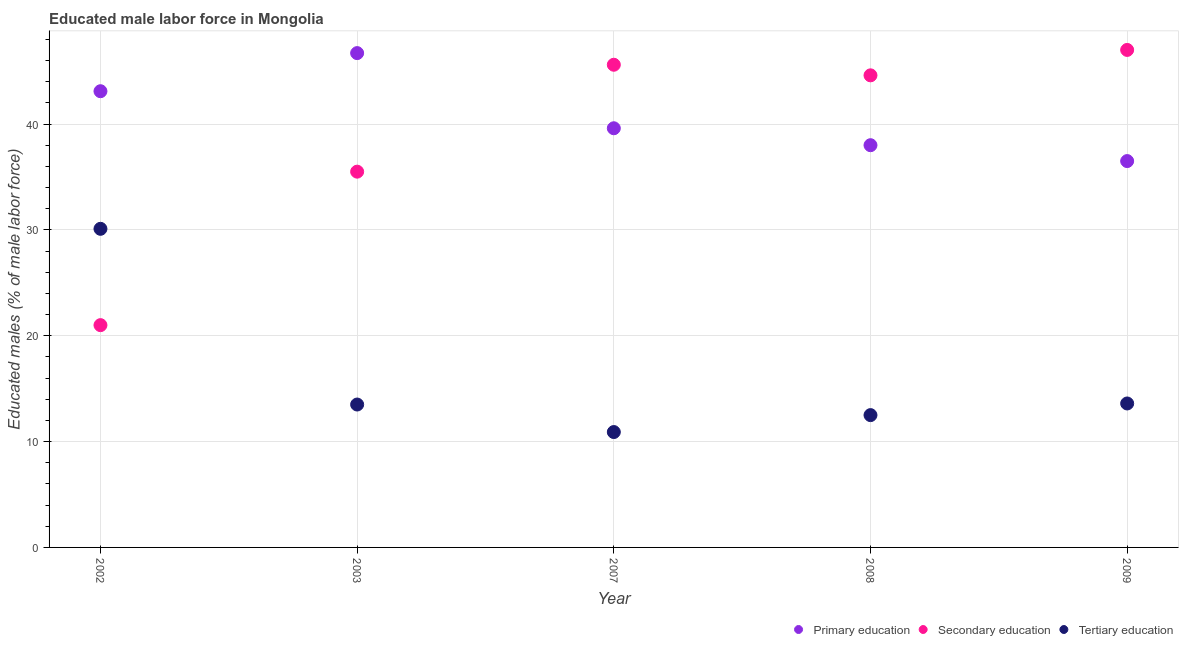How many different coloured dotlines are there?
Keep it short and to the point. 3. What is the percentage of male labor force who received primary education in 2007?
Your answer should be compact. 39.6. Across all years, what is the maximum percentage of male labor force who received secondary education?
Offer a terse response. 47. Across all years, what is the minimum percentage of male labor force who received tertiary education?
Give a very brief answer. 10.9. In which year was the percentage of male labor force who received tertiary education maximum?
Offer a very short reply. 2002. In which year was the percentage of male labor force who received tertiary education minimum?
Ensure brevity in your answer.  2007. What is the total percentage of male labor force who received primary education in the graph?
Keep it short and to the point. 203.9. What is the difference between the percentage of male labor force who received tertiary education in 2008 and that in 2009?
Your answer should be compact. -1.1. What is the difference between the percentage of male labor force who received primary education in 2003 and the percentage of male labor force who received secondary education in 2002?
Offer a terse response. 25.7. What is the average percentage of male labor force who received primary education per year?
Your answer should be compact. 40.78. In the year 2003, what is the difference between the percentage of male labor force who received tertiary education and percentage of male labor force who received primary education?
Ensure brevity in your answer.  -33.2. What is the ratio of the percentage of male labor force who received primary education in 2003 to that in 2009?
Keep it short and to the point. 1.28. Is the percentage of male labor force who received primary education in 2008 less than that in 2009?
Give a very brief answer. No. Is the difference between the percentage of male labor force who received tertiary education in 2007 and 2009 greater than the difference between the percentage of male labor force who received secondary education in 2007 and 2009?
Ensure brevity in your answer.  No. What is the difference between the highest and the second highest percentage of male labor force who received secondary education?
Make the answer very short. 1.4. What is the difference between the highest and the lowest percentage of male labor force who received primary education?
Make the answer very short. 10.2. Is the sum of the percentage of male labor force who received tertiary education in 2007 and 2008 greater than the maximum percentage of male labor force who received primary education across all years?
Offer a terse response. No. Is it the case that in every year, the sum of the percentage of male labor force who received primary education and percentage of male labor force who received secondary education is greater than the percentage of male labor force who received tertiary education?
Provide a succinct answer. Yes. Does the percentage of male labor force who received primary education monotonically increase over the years?
Give a very brief answer. No. How many dotlines are there?
Provide a short and direct response. 3. How many years are there in the graph?
Give a very brief answer. 5. What is the difference between two consecutive major ticks on the Y-axis?
Your answer should be very brief. 10. Are the values on the major ticks of Y-axis written in scientific E-notation?
Your answer should be very brief. No. Does the graph contain any zero values?
Offer a very short reply. No. How many legend labels are there?
Offer a terse response. 3. How are the legend labels stacked?
Your answer should be compact. Horizontal. What is the title of the graph?
Give a very brief answer. Educated male labor force in Mongolia. What is the label or title of the X-axis?
Keep it short and to the point. Year. What is the label or title of the Y-axis?
Keep it short and to the point. Educated males (% of male labor force). What is the Educated males (% of male labor force) in Primary education in 2002?
Offer a terse response. 43.1. What is the Educated males (% of male labor force) of Secondary education in 2002?
Provide a short and direct response. 21. What is the Educated males (% of male labor force) in Tertiary education in 2002?
Provide a succinct answer. 30.1. What is the Educated males (% of male labor force) in Primary education in 2003?
Offer a very short reply. 46.7. What is the Educated males (% of male labor force) in Secondary education in 2003?
Keep it short and to the point. 35.5. What is the Educated males (% of male labor force) in Primary education in 2007?
Offer a very short reply. 39.6. What is the Educated males (% of male labor force) of Secondary education in 2007?
Your answer should be very brief. 45.6. What is the Educated males (% of male labor force) of Tertiary education in 2007?
Give a very brief answer. 10.9. What is the Educated males (% of male labor force) in Primary education in 2008?
Your response must be concise. 38. What is the Educated males (% of male labor force) of Secondary education in 2008?
Offer a very short reply. 44.6. What is the Educated males (% of male labor force) in Tertiary education in 2008?
Provide a short and direct response. 12.5. What is the Educated males (% of male labor force) in Primary education in 2009?
Your answer should be compact. 36.5. What is the Educated males (% of male labor force) in Tertiary education in 2009?
Make the answer very short. 13.6. Across all years, what is the maximum Educated males (% of male labor force) in Primary education?
Make the answer very short. 46.7. Across all years, what is the maximum Educated males (% of male labor force) of Tertiary education?
Keep it short and to the point. 30.1. Across all years, what is the minimum Educated males (% of male labor force) in Primary education?
Offer a very short reply. 36.5. Across all years, what is the minimum Educated males (% of male labor force) in Secondary education?
Offer a terse response. 21. Across all years, what is the minimum Educated males (% of male labor force) in Tertiary education?
Give a very brief answer. 10.9. What is the total Educated males (% of male labor force) in Primary education in the graph?
Keep it short and to the point. 203.9. What is the total Educated males (% of male labor force) of Secondary education in the graph?
Give a very brief answer. 193.7. What is the total Educated males (% of male labor force) of Tertiary education in the graph?
Keep it short and to the point. 80.6. What is the difference between the Educated males (% of male labor force) in Secondary education in 2002 and that in 2003?
Keep it short and to the point. -14.5. What is the difference between the Educated males (% of male labor force) in Tertiary education in 2002 and that in 2003?
Offer a very short reply. 16.6. What is the difference between the Educated males (% of male labor force) of Primary education in 2002 and that in 2007?
Ensure brevity in your answer.  3.5. What is the difference between the Educated males (% of male labor force) in Secondary education in 2002 and that in 2007?
Your answer should be very brief. -24.6. What is the difference between the Educated males (% of male labor force) of Primary education in 2002 and that in 2008?
Offer a very short reply. 5.1. What is the difference between the Educated males (% of male labor force) of Secondary education in 2002 and that in 2008?
Your answer should be compact. -23.6. What is the difference between the Educated males (% of male labor force) of Tertiary education in 2002 and that in 2008?
Give a very brief answer. 17.6. What is the difference between the Educated males (% of male labor force) in Primary education in 2002 and that in 2009?
Ensure brevity in your answer.  6.6. What is the difference between the Educated males (% of male labor force) in Secondary education in 2003 and that in 2007?
Your response must be concise. -10.1. What is the difference between the Educated males (% of male labor force) in Tertiary education in 2003 and that in 2007?
Offer a very short reply. 2.6. What is the difference between the Educated males (% of male labor force) of Secondary education in 2003 and that in 2008?
Your answer should be very brief. -9.1. What is the difference between the Educated males (% of male labor force) of Primary education in 2003 and that in 2009?
Make the answer very short. 10.2. What is the difference between the Educated males (% of male labor force) in Tertiary education in 2003 and that in 2009?
Keep it short and to the point. -0.1. What is the difference between the Educated males (% of male labor force) of Primary education in 2007 and that in 2008?
Your response must be concise. 1.6. What is the difference between the Educated males (% of male labor force) of Tertiary education in 2007 and that in 2008?
Keep it short and to the point. -1.6. What is the difference between the Educated males (% of male labor force) in Primary education in 2002 and the Educated males (% of male labor force) in Tertiary education in 2003?
Your answer should be very brief. 29.6. What is the difference between the Educated males (% of male labor force) of Secondary education in 2002 and the Educated males (% of male labor force) of Tertiary education in 2003?
Provide a short and direct response. 7.5. What is the difference between the Educated males (% of male labor force) of Primary education in 2002 and the Educated males (% of male labor force) of Secondary education in 2007?
Ensure brevity in your answer.  -2.5. What is the difference between the Educated males (% of male labor force) in Primary education in 2002 and the Educated males (% of male labor force) in Tertiary education in 2007?
Provide a short and direct response. 32.2. What is the difference between the Educated males (% of male labor force) of Primary education in 2002 and the Educated males (% of male labor force) of Secondary education in 2008?
Your response must be concise. -1.5. What is the difference between the Educated males (% of male labor force) of Primary education in 2002 and the Educated males (% of male labor force) of Tertiary education in 2008?
Keep it short and to the point. 30.6. What is the difference between the Educated males (% of male labor force) in Secondary education in 2002 and the Educated males (% of male labor force) in Tertiary education in 2008?
Your answer should be very brief. 8.5. What is the difference between the Educated males (% of male labor force) of Primary education in 2002 and the Educated males (% of male labor force) of Tertiary education in 2009?
Provide a short and direct response. 29.5. What is the difference between the Educated males (% of male labor force) in Primary education in 2003 and the Educated males (% of male labor force) in Tertiary education in 2007?
Your answer should be very brief. 35.8. What is the difference between the Educated males (% of male labor force) in Secondary education in 2003 and the Educated males (% of male labor force) in Tertiary education in 2007?
Your answer should be very brief. 24.6. What is the difference between the Educated males (% of male labor force) in Primary education in 2003 and the Educated males (% of male labor force) in Secondary education in 2008?
Your response must be concise. 2.1. What is the difference between the Educated males (% of male labor force) of Primary education in 2003 and the Educated males (% of male labor force) of Tertiary education in 2008?
Offer a very short reply. 34.2. What is the difference between the Educated males (% of male labor force) of Primary education in 2003 and the Educated males (% of male labor force) of Tertiary education in 2009?
Offer a terse response. 33.1. What is the difference between the Educated males (% of male labor force) in Secondary education in 2003 and the Educated males (% of male labor force) in Tertiary education in 2009?
Make the answer very short. 21.9. What is the difference between the Educated males (% of male labor force) in Primary education in 2007 and the Educated males (% of male labor force) in Tertiary education in 2008?
Provide a succinct answer. 27.1. What is the difference between the Educated males (% of male labor force) of Secondary education in 2007 and the Educated males (% of male labor force) of Tertiary education in 2008?
Make the answer very short. 33.1. What is the difference between the Educated males (% of male labor force) of Secondary education in 2007 and the Educated males (% of male labor force) of Tertiary education in 2009?
Make the answer very short. 32. What is the difference between the Educated males (% of male labor force) of Primary education in 2008 and the Educated males (% of male labor force) of Tertiary education in 2009?
Your answer should be very brief. 24.4. What is the difference between the Educated males (% of male labor force) of Secondary education in 2008 and the Educated males (% of male labor force) of Tertiary education in 2009?
Keep it short and to the point. 31. What is the average Educated males (% of male labor force) of Primary education per year?
Make the answer very short. 40.78. What is the average Educated males (% of male labor force) in Secondary education per year?
Make the answer very short. 38.74. What is the average Educated males (% of male labor force) of Tertiary education per year?
Your answer should be very brief. 16.12. In the year 2002, what is the difference between the Educated males (% of male labor force) of Primary education and Educated males (% of male labor force) of Secondary education?
Give a very brief answer. 22.1. In the year 2003, what is the difference between the Educated males (% of male labor force) of Primary education and Educated males (% of male labor force) of Secondary education?
Ensure brevity in your answer.  11.2. In the year 2003, what is the difference between the Educated males (% of male labor force) of Primary education and Educated males (% of male labor force) of Tertiary education?
Provide a short and direct response. 33.2. In the year 2007, what is the difference between the Educated males (% of male labor force) of Primary education and Educated males (% of male labor force) of Tertiary education?
Offer a very short reply. 28.7. In the year 2007, what is the difference between the Educated males (% of male labor force) in Secondary education and Educated males (% of male labor force) in Tertiary education?
Ensure brevity in your answer.  34.7. In the year 2008, what is the difference between the Educated males (% of male labor force) in Primary education and Educated males (% of male labor force) in Secondary education?
Keep it short and to the point. -6.6. In the year 2008, what is the difference between the Educated males (% of male labor force) in Secondary education and Educated males (% of male labor force) in Tertiary education?
Make the answer very short. 32.1. In the year 2009, what is the difference between the Educated males (% of male labor force) of Primary education and Educated males (% of male labor force) of Secondary education?
Your response must be concise. -10.5. In the year 2009, what is the difference between the Educated males (% of male labor force) of Primary education and Educated males (% of male labor force) of Tertiary education?
Your answer should be very brief. 22.9. In the year 2009, what is the difference between the Educated males (% of male labor force) of Secondary education and Educated males (% of male labor force) of Tertiary education?
Provide a short and direct response. 33.4. What is the ratio of the Educated males (% of male labor force) of Primary education in 2002 to that in 2003?
Ensure brevity in your answer.  0.92. What is the ratio of the Educated males (% of male labor force) in Secondary education in 2002 to that in 2003?
Your answer should be compact. 0.59. What is the ratio of the Educated males (% of male labor force) of Tertiary education in 2002 to that in 2003?
Give a very brief answer. 2.23. What is the ratio of the Educated males (% of male labor force) in Primary education in 2002 to that in 2007?
Ensure brevity in your answer.  1.09. What is the ratio of the Educated males (% of male labor force) of Secondary education in 2002 to that in 2007?
Your answer should be very brief. 0.46. What is the ratio of the Educated males (% of male labor force) of Tertiary education in 2002 to that in 2007?
Give a very brief answer. 2.76. What is the ratio of the Educated males (% of male labor force) of Primary education in 2002 to that in 2008?
Your answer should be compact. 1.13. What is the ratio of the Educated males (% of male labor force) of Secondary education in 2002 to that in 2008?
Make the answer very short. 0.47. What is the ratio of the Educated males (% of male labor force) in Tertiary education in 2002 to that in 2008?
Make the answer very short. 2.41. What is the ratio of the Educated males (% of male labor force) in Primary education in 2002 to that in 2009?
Give a very brief answer. 1.18. What is the ratio of the Educated males (% of male labor force) of Secondary education in 2002 to that in 2009?
Provide a short and direct response. 0.45. What is the ratio of the Educated males (% of male labor force) of Tertiary education in 2002 to that in 2009?
Provide a succinct answer. 2.21. What is the ratio of the Educated males (% of male labor force) of Primary education in 2003 to that in 2007?
Provide a short and direct response. 1.18. What is the ratio of the Educated males (% of male labor force) of Secondary education in 2003 to that in 2007?
Ensure brevity in your answer.  0.78. What is the ratio of the Educated males (% of male labor force) in Tertiary education in 2003 to that in 2007?
Ensure brevity in your answer.  1.24. What is the ratio of the Educated males (% of male labor force) of Primary education in 2003 to that in 2008?
Offer a very short reply. 1.23. What is the ratio of the Educated males (% of male labor force) in Secondary education in 2003 to that in 2008?
Make the answer very short. 0.8. What is the ratio of the Educated males (% of male labor force) of Primary education in 2003 to that in 2009?
Your answer should be very brief. 1.28. What is the ratio of the Educated males (% of male labor force) of Secondary education in 2003 to that in 2009?
Offer a very short reply. 0.76. What is the ratio of the Educated males (% of male labor force) in Tertiary education in 2003 to that in 2009?
Your response must be concise. 0.99. What is the ratio of the Educated males (% of male labor force) of Primary education in 2007 to that in 2008?
Offer a terse response. 1.04. What is the ratio of the Educated males (% of male labor force) in Secondary education in 2007 to that in 2008?
Provide a succinct answer. 1.02. What is the ratio of the Educated males (% of male labor force) in Tertiary education in 2007 to that in 2008?
Your answer should be compact. 0.87. What is the ratio of the Educated males (% of male labor force) in Primary education in 2007 to that in 2009?
Offer a very short reply. 1.08. What is the ratio of the Educated males (% of male labor force) of Secondary education in 2007 to that in 2009?
Provide a short and direct response. 0.97. What is the ratio of the Educated males (% of male labor force) of Tertiary education in 2007 to that in 2009?
Ensure brevity in your answer.  0.8. What is the ratio of the Educated males (% of male labor force) of Primary education in 2008 to that in 2009?
Give a very brief answer. 1.04. What is the ratio of the Educated males (% of male labor force) in Secondary education in 2008 to that in 2009?
Ensure brevity in your answer.  0.95. What is the ratio of the Educated males (% of male labor force) of Tertiary education in 2008 to that in 2009?
Provide a short and direct response. 0.92. What is the difference between the highest and the second highest Educated males (% of male labor force) of Primary education?
Offer a terse response. 3.6. What is the difference between the highest and the second highest Educated males (% of male labor force) in Secondary education?
Your answer should be compact. 1.4. What is the difference between the highest and the second highest Educated males (% of male labor force) in Tertiary education?
Ensure brevity in your answer.  16.5. What is the difference between the highest and the lowest Educated males (% of male labor force) in Primary education?
Your answer should be very brief. 10.2. What is the difference between the highest and the lowest Educated males (% of male labor force) in Secondary education?
Your response must be concise. 26. 